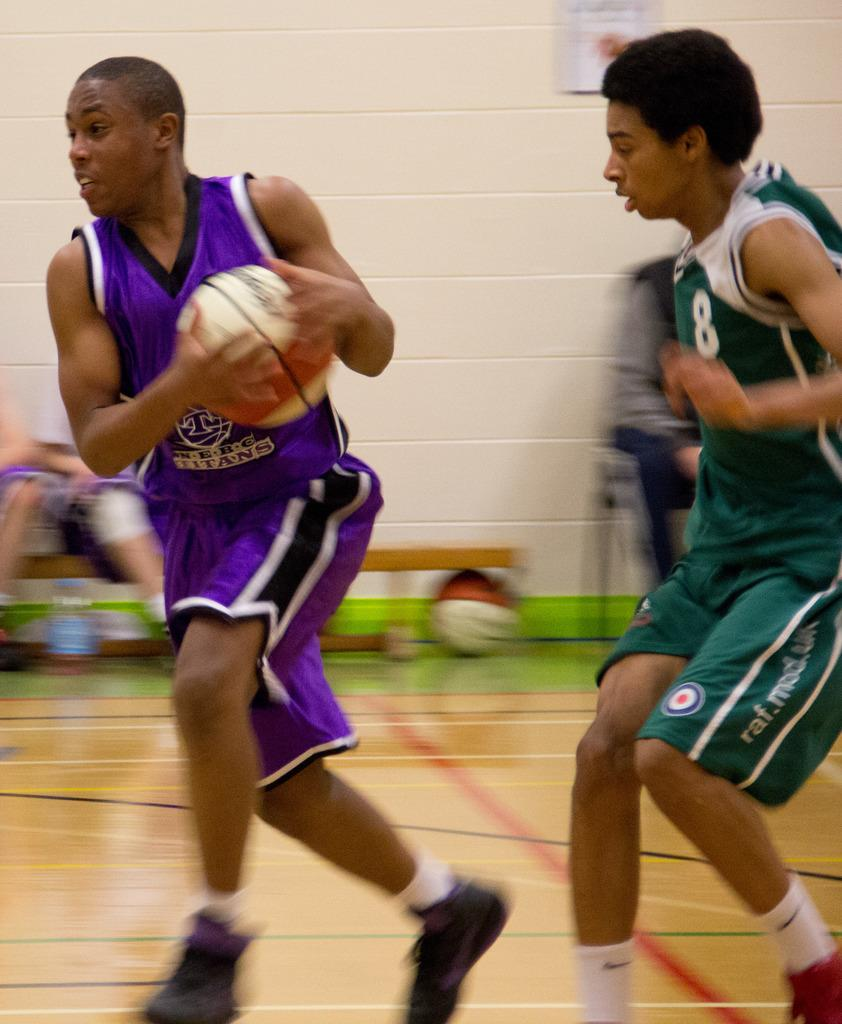<image>
Share a concise interpretation of the image provided. number 8 is trying to get to the basketball player with the ball 